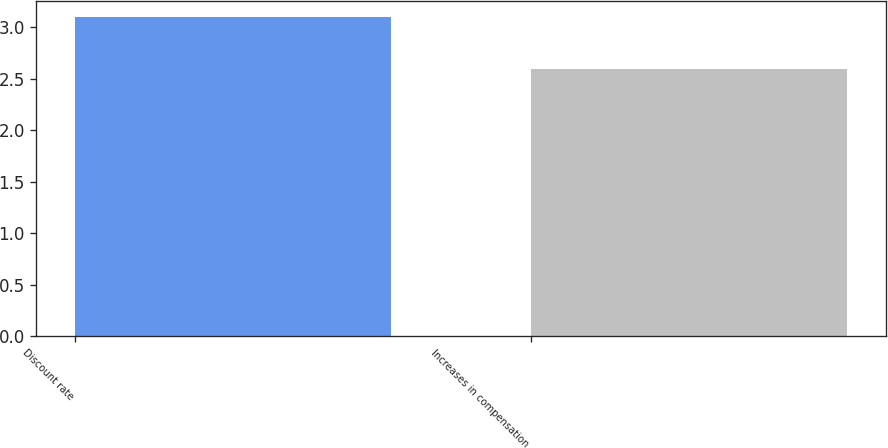<chart> <loc_0><loc_0><loc_500><loc_500><bar_chart><fcel>Discount rate<fcel>Increases in compensation<nl><fcel>3.1<fcel>2.59<nl></chart> 